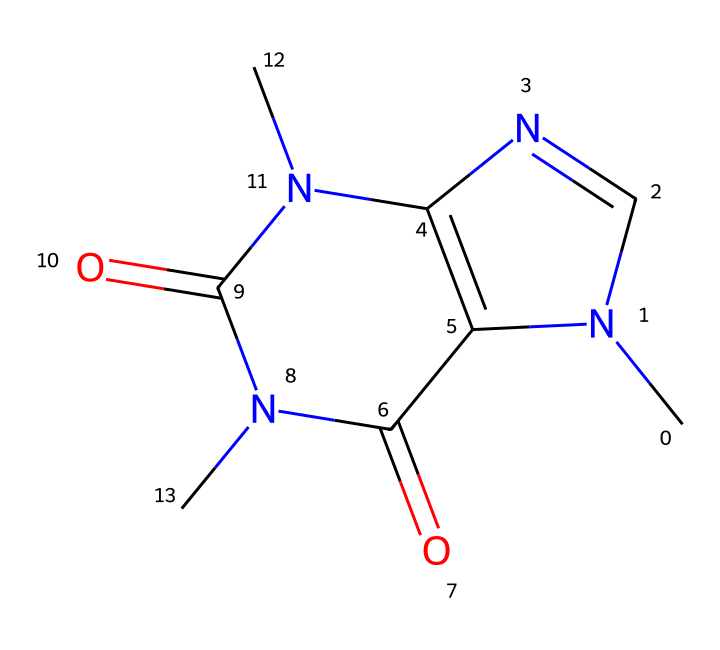How many nitrogen atoms are in this molecule? By examining the SMILES representation, we can identify the occurrences of the nitrogen atom (N). Counting the instances of nitrogen, there are three distinct nitrogen atoms present in the structure.
Answer: three What is the overall charge of caffeine? The molecular structure does not indicate any ionic charges or groups; therefore, caffeine is neutral as shown in the structure, confirming no net charge.
Answer: neutral Which functional groups are present in caffeine? The SMILES representation reveals that caffeine contains a carbonyl group (C=O) and amine groups (N). The presence of these groups can be inferred from the nitrogen and oxygen placements.
Answer: carbonyl and amine What is the molecular formula of caffeine? Analyzing the entire structure leads us to count the atoms: there are 8 carbon atoms, 10 hydrogen atoms, 4 nitrogen atoms, and 2 oxygen atoms. This gives us the molecular formula C8H10N4O2 for caffeine.
Answer: C8H10N4O2 Is caffeine an alkaloid? Caffeine is classified as an alkaloid, which is a naturally occurring compound that typically contains nitrogen. The presence of nitrogen atoms in its structure supports this classification.
Answer: yes What type of bonding is present in caffeine? The structure represents covalent bonds, characterized by the sharing of electrons between atoms, evident from the connectivity of carbon, nitrogen, and oxygen in the molecule.
Answer: covalent Does caffeine have a ring structure? The SMILES describes a cyclic structure due to the presence of interconnected atoms forming rings, as noted in the arrangement of carbon and nitrogen atoms, indicating a polycyclic aromatic structure.
Answer: yes 